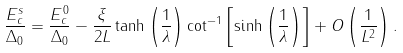Convert formula to latex. <formula><loc_0><loc_0><loc_500><loc_500>\frac { E _ { c } ^ { s } } { \Delta _ { 0 } } = \frac { E _ { c } ^ { 0 } } { \Delta _ { 0 } } - \frac { \xi } { 2 L } \tanh \left ( \frac { 1 } { \lambda } \right ) \cot ^ { - 1 } \left [ \sinh \left ( \frac { 1 } { \lambda } \right ) \right ] + O \left ( \frac { 1 } { L ^ { 2 } } \right ) .</formula> 